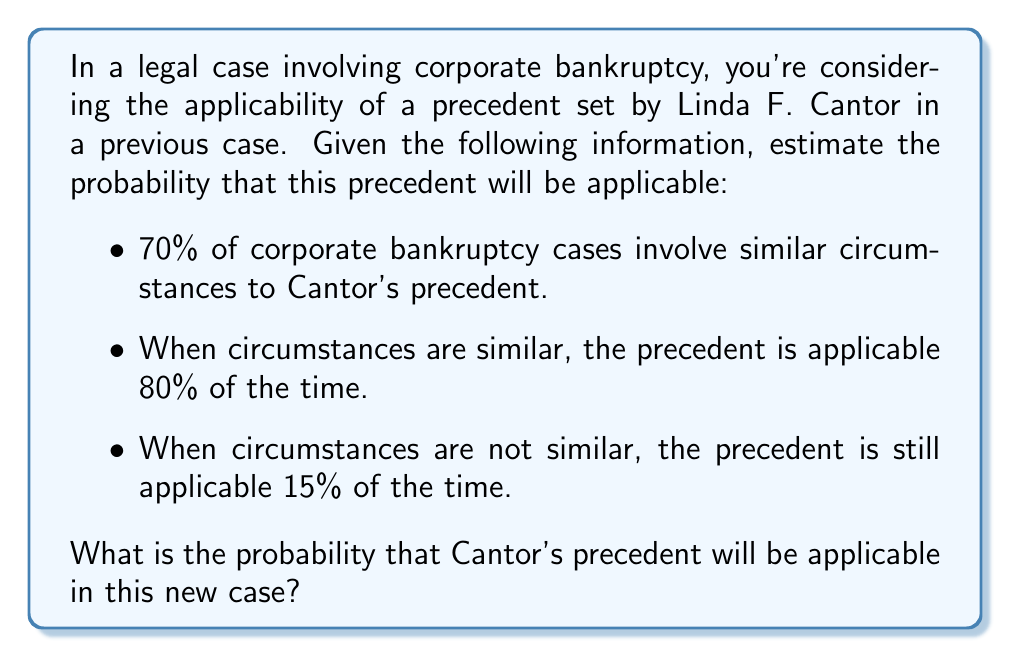Can you answer this question? To solve this problem, we'll use Bayes' theorem and the law of total probability. Let's define our events:

A: The precedent is applicable
B: The case involves similar circumstances

Given:
P(B) = 0.70 (70% of cases involve similar circumstances)
P(A|B) = 0.80 (80% applicability when circumstances are similar)
P(A|not B) = 0.15 (15% applicability when circumstances are not similar)

Step 1: Calculate P(not B)
P(not B) = 1 - P(B) = 1 - 0.70 = 0.30

Step 2: Use the law of total probability to calculate P(A)
$$P(A) = P(A|B) \cdot P(B) + P(A|not B) \cdot P(not B)$$
$$P(A) = 0.80 \cdot 0.70 + 0.15 \cdot 0.30$$
$$P(A) = 0.56 + 0.045 = 0.605$$

Therefore, the probability that Cantor's precedent will be applicable in this new case is 0.605 or 60.5%.
Answer: 0.605 or 60.5% 